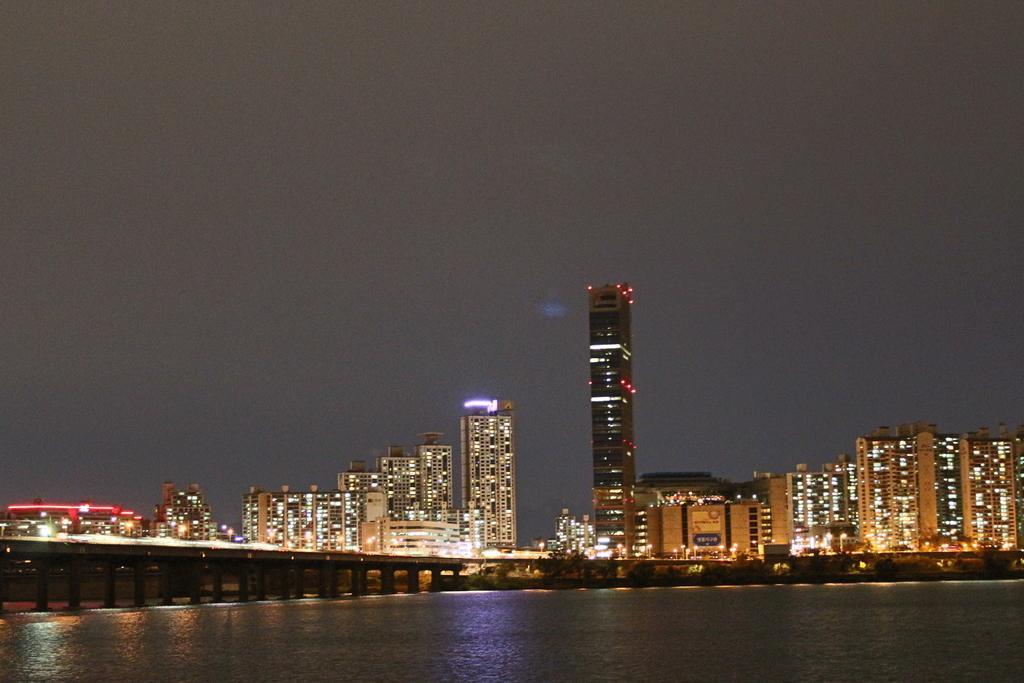In one or two sentences, can you explain what this image depicts? In the background of the image there are buildings with lights. There is a bridge. At the bottom of the image there is water. At the top of the image there is sky. 